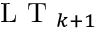Convert formula to latex. <formula><loc_0><loc_0><loc_500><loc_500>L T _ { k + 1 }</formula> 